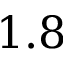<formula> <loc_0><loc_0><loc_500><loc_500>1 . 8</formula> 